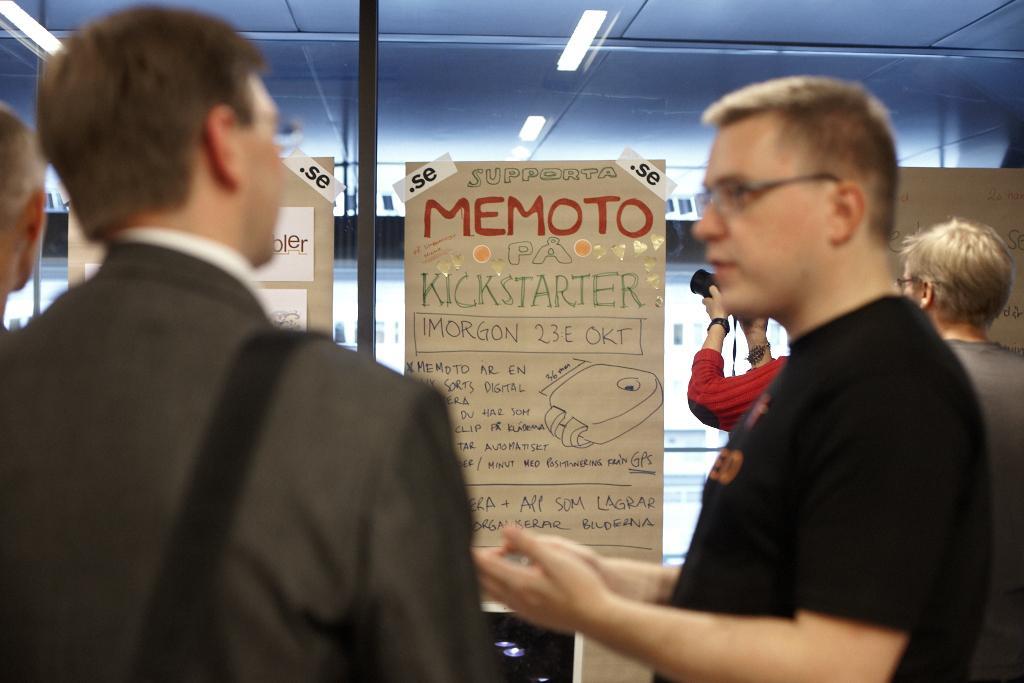In one or two sentences, can you explain what this image depicts? In this picture I can see the charts on the glass wall. I can see a person holding the camera on the right side. I can see the people. 